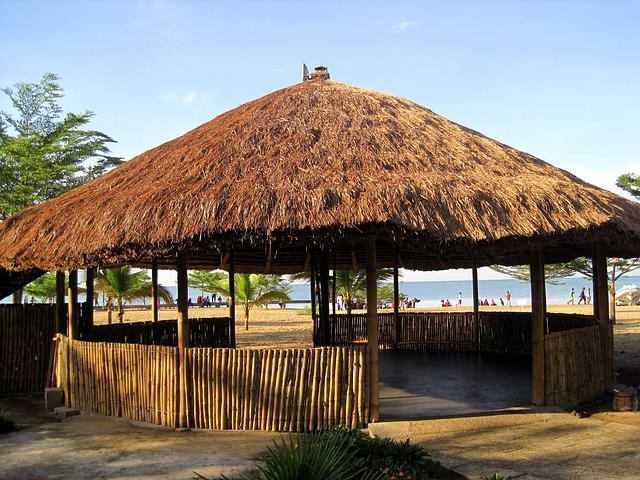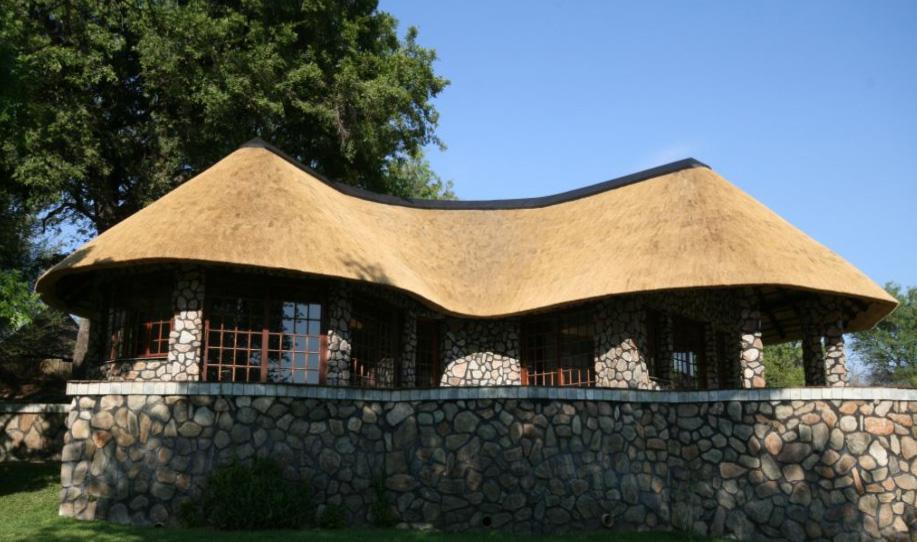The first image is the image on the left, the second image is the image on the right. Considering the images on both sides, is "The right image shows an exterior with a bench to the right of a narrow rectangular pool, and behind the pool large glass doors with a chimney above them in front of a dark roof." valid? Answer yes or no. No. 